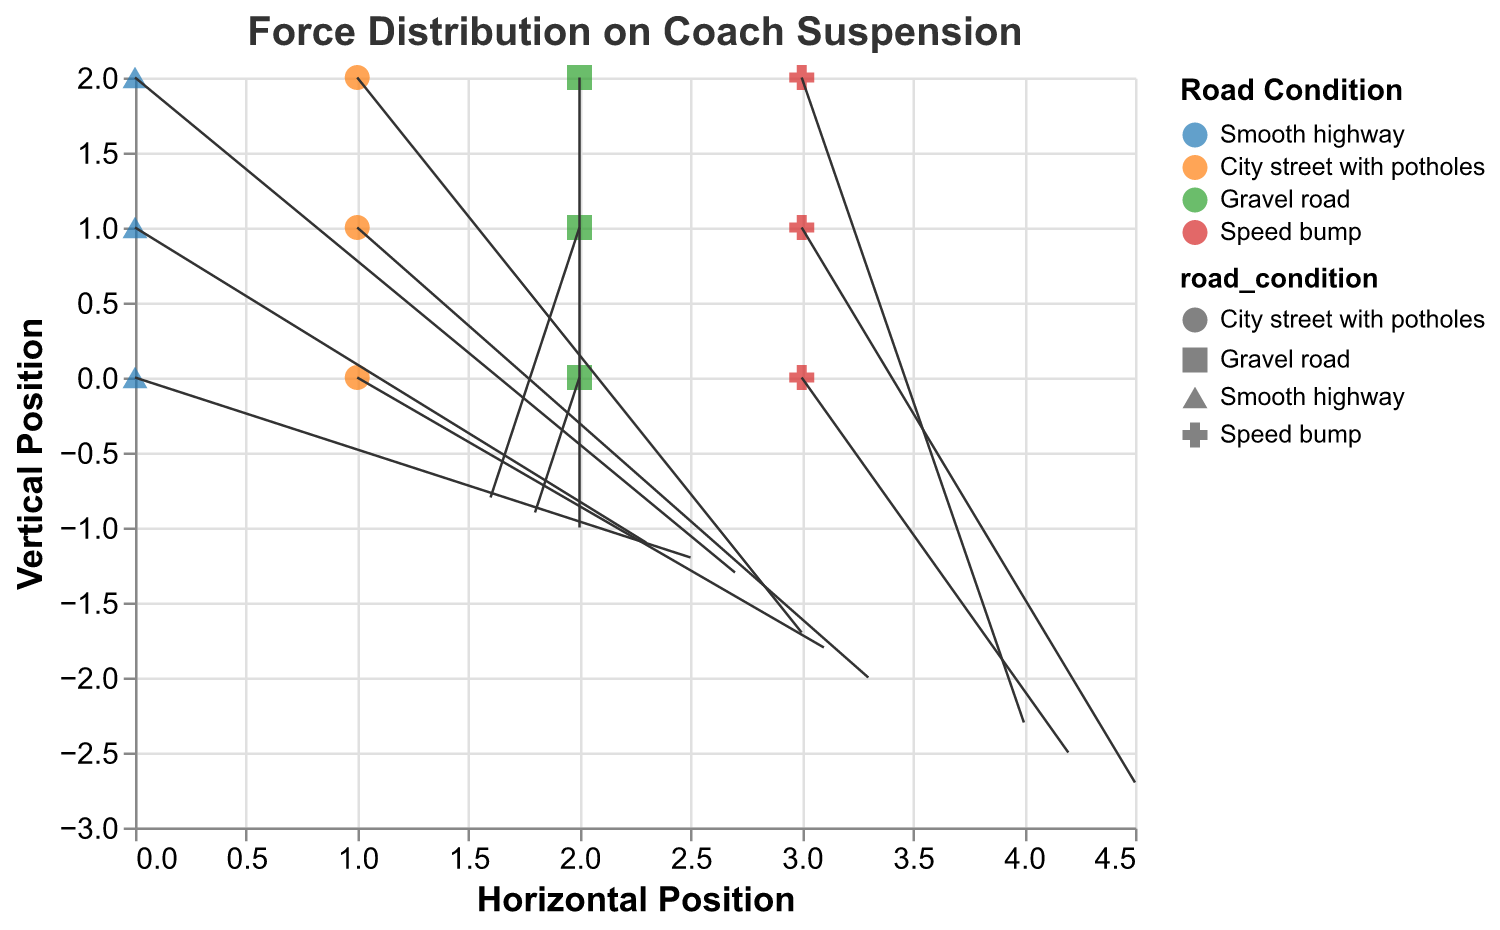What's the title of the figure? The title of the figure is clearly mentioned at the top of the plot.
Answer: "Force Distribution on Coach Suspension" What are the labels on the x and y axes? The labels are shown next to the axes in the plot. The x-axis is labeled "Horizontal Position," and the y-axis is labeled "Vertical Position."
Answer: "Horizontal Position" and "Vertical Position" How many different road conditions are represented? The legend of the plot identifies the different road conditions by color. There are four categories.
Answer: 4 Which road condition has the highest force vector magnitude? To determine this, calculate the magnitudes of the vectors for each road condition and compare them. Speed bump has consistently larger vector magnitudes compared to others.
Answer: "Speed bump" What is the force vector at point (0, 1) on the plot? Locate the point (0, 1). The corresponding force vector (u, v) at that point is (2.3, -1.1).
Answer: (2.3, -1.1) Compare the force vectors at point (3, 0) and (3, 1). Which one has a greater magnitude? Calculate the magnitudes: sqrt(4.2^2 + (-2.5)^2) ≈ 4.9 for point (3, 0) and sqrt(4.5^2 + (-2.7)^2) ≈ 5.2 for point (3, 1). Point (3, 1) has a greater magnitude.
Answer: (3, 1) What is the road condition associated with the vector (3.1, -1.8)? This can be found from the data binding, where the vector (3.1, -1.8) is associated with the "City street with potholes" road condition.
Answer: "City street with potholes" On which road condition does the point (2, 1) lie? Find the point (2, 1). The vector at this point is 1.6, -0.8, corresponding to "Gravel road."
Answer: "Gravel road" What is the total horizontal force on a Smooth highway at the y positions 0, 1, and 2? Sum the horizontal forces (u): 2.5 + 2.3 + 2.7 = 7.5
Answer: 7.5 Which point has the smallest vertical force component (v) on a Speed bump? Compare the vertical forces for Speed bump across all points: -2.5, -2.7, and -2.3. The smallest component is -2.7 at point (3, 1).
Answer: (3, 1) 